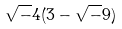Convert formula to latex. <formula><loc_0><loc_0><loc_500><loc_500>\sqrt { - } 4 ( 3 - \sqrt { - } 9 )</formula> 